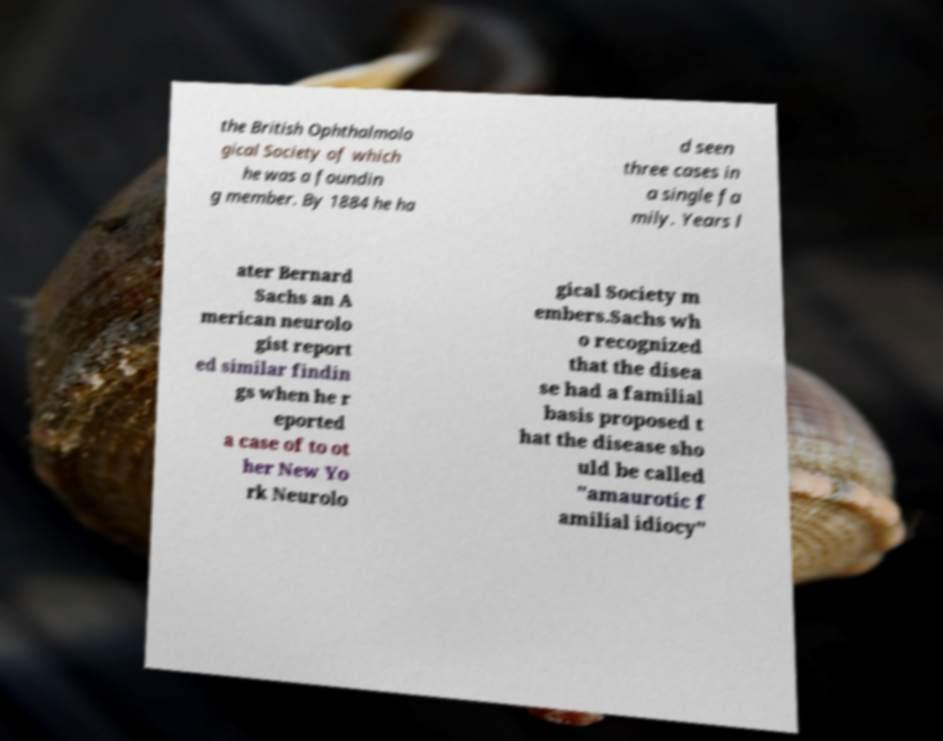Can you read and provide the text displayed in the image?This photo seems to have some interesting text. Can you extract and type it out for me? the British Ophthalmolo gical Society of which he was a foundin g member. By 1884 he ha d seen three cases in a single fa mily. Years l ater Bernard Sachs an A merican neurolo gist report ed similar findin gs when he r eported a case of to ot her New Yo rk Neurolo gical Society m embers.Sachs wh o recognized that the disea se had a familial basis proposed t hat the disease sho uld be called "amaurotic f amilial idiocy" 